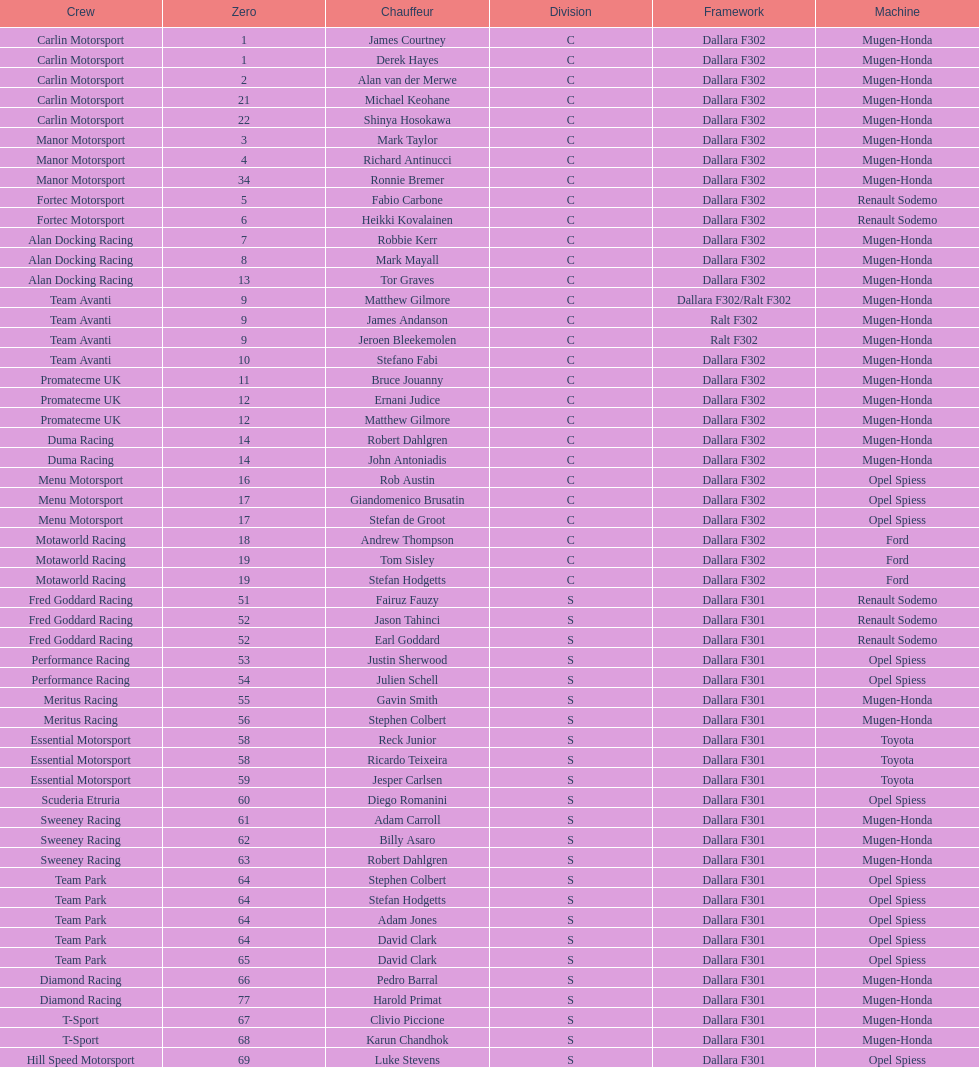Who had more drivers, team avanti or motaworld racing? Team Avanti. 